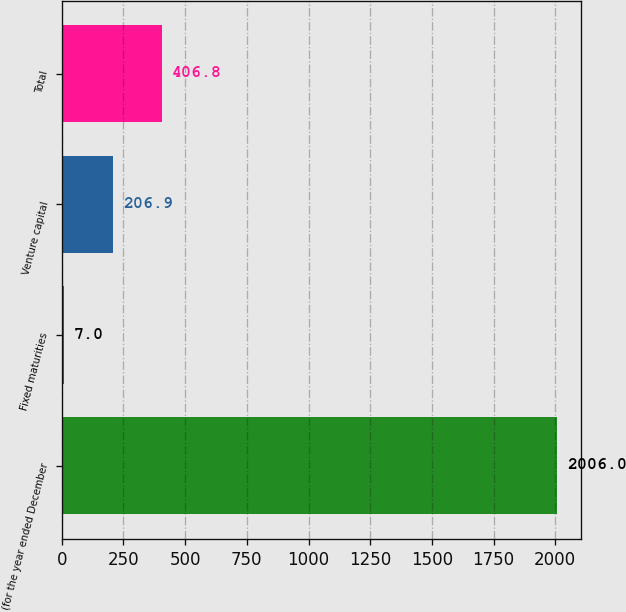Convert chart. <chart><loc_0><loc_0><loc_500><loc_500><bar_chart><fcel>(for the year ended December<fcel>Fixed maturities<fcel>Venture capital<fcel>Total<nl><fcel>2006<fcel>7<fcel>206.9<fcel>406.8<nl></chart> 